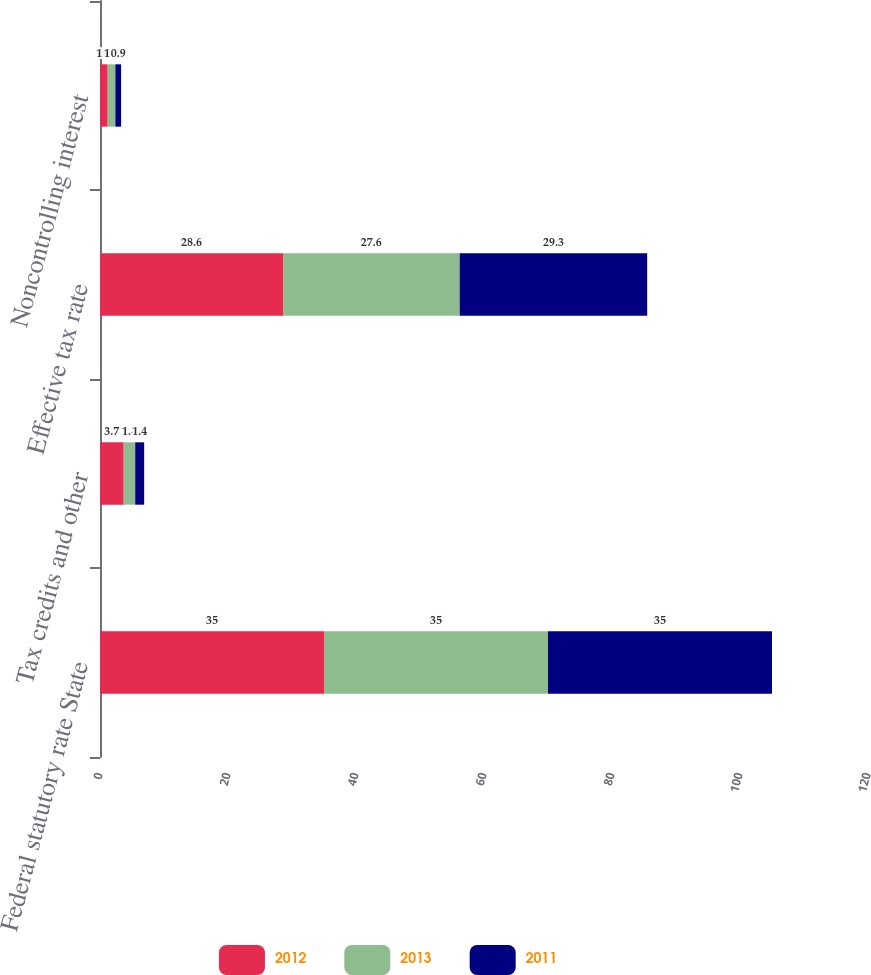<chart> <loc_0><loc_0><loc_500><loc_500><stacked_bar_chart><ecel><fcel>Federal statutory rate State<fcel>Tax credits and other<fcel>Effective tax rate<fcel>Noncontrolling interest<nl><fcel>2012<fcel>35<fcel>3.7<fcel>28.6<fcel>1.2<nl><fcel>2013<fcel>35<fcel>1.8<fcel>27.6<fcel>1.2<nl><fcel>2011<fcel>35<fcel>1.4<fcel>29.3<fcel>0.9<nl></chart> 